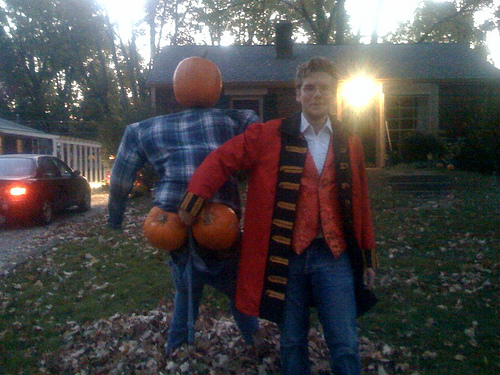<image>
Is there a pumpkin behind the car? No. The pumpkin is not behind the car. From this viewpoint, the pumpkin appears to be positioned elsewhere in the scene. Where is the jeans in relation to the boy? Is it on the boy? No. The jeans is not positioned on the boy. They may be near each other, but the jeans is not supported by or resting on top of the boy. 